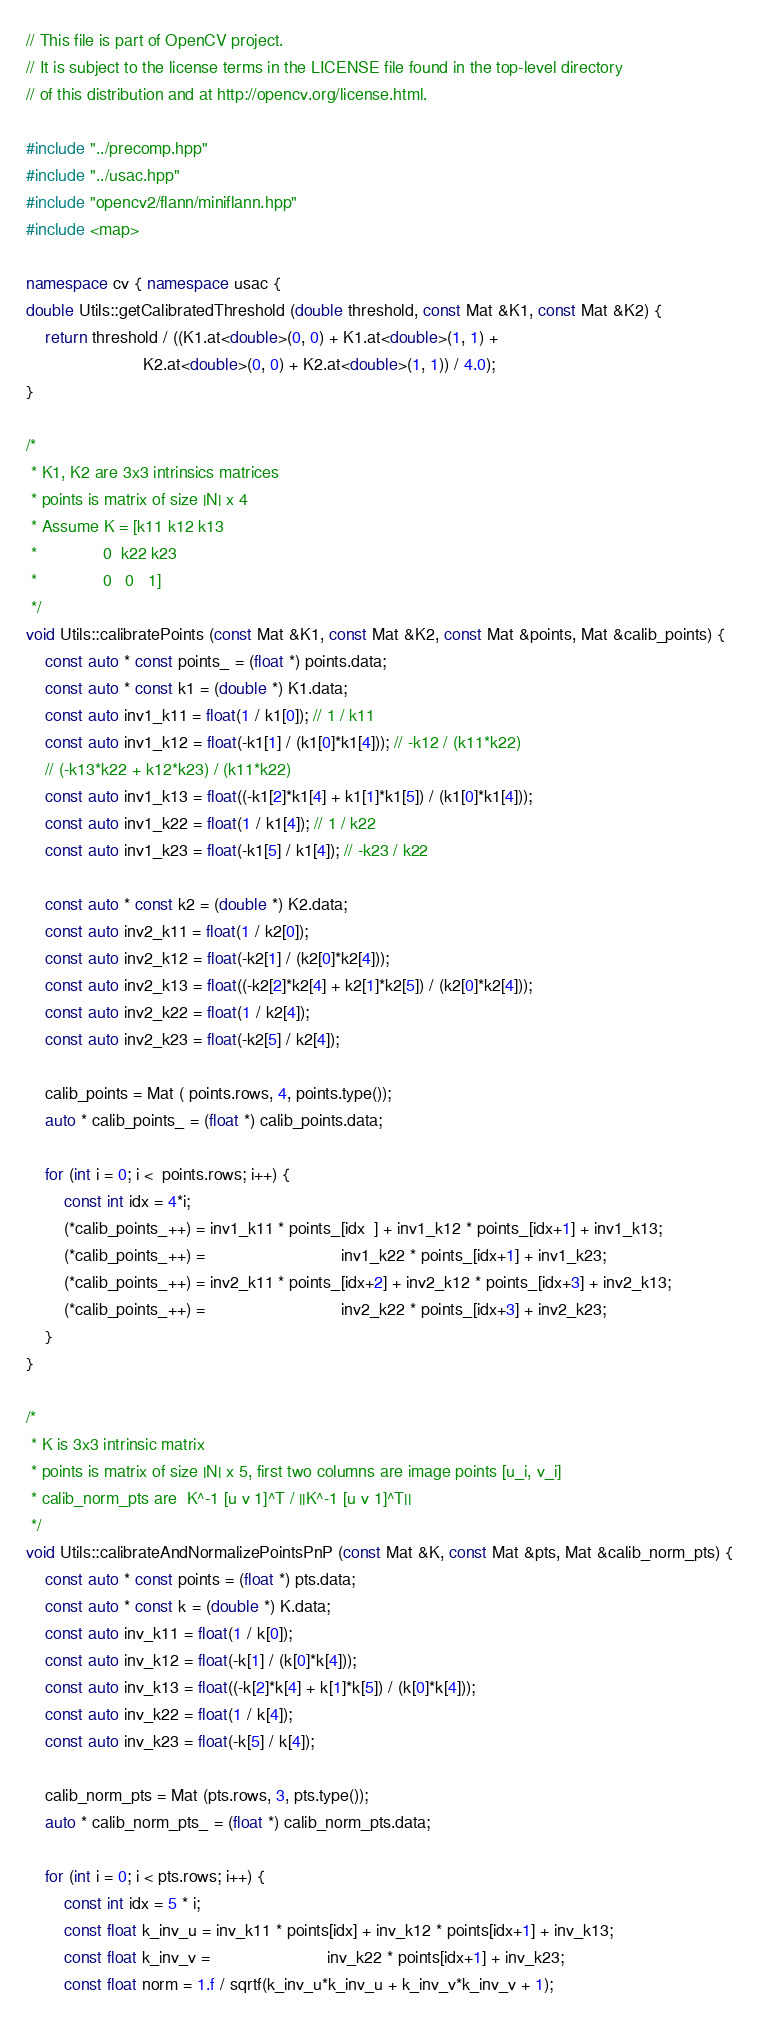<code> <loc_0><loc_0><loc_500><loc_500><_C++_>// This file is part of OpenCV project.
// It is subject to the license terms in the LICENSE file found in the top-level directory
// of this distribution and at http://opencv.org/license.html.

#include "../precomp.hpp"
#include "../usac.hpp"
#include "opencv2/flann/miniflann.hpp"
#include <map>

namespace cv { namespace usac {
double Utils::getCalibratedThreshold (double threshold, const Mat &K1, const Mat &K2) {
    return threshold / ((K1.at<double>(0, 0) + K1.at<double>(1, 1) +
                         K2.at<double>(0, 0) + K2.at<double>(1, 1)) / 4.0);
}

/*
 * K1, K2 are 3x3 intrinsics matrices
 * points is matrix of size |N| x 4
 * Assume K = [k11 k12 k13
 *              0  k22 k23
 *              0   0   1]
 */
void Utils::calibratePoints (const Mat &K1, const Mat &K2, const Mat &points, Mat &calib_points) {
    const auto * const points_ = (float *) points.data;
    const auto * const k1 = (double *) K1.data;
    const auto inv1_k11 = float(1 / k1[0]); // 1 / k11
    const auto inv1_k12 = float(-k1[1] / (k1[0]*k1[4])); // -k12 / (k11*k22)
    // (-k13*k22 + k12*k23) / (k11*k22)
    const auto inv1_k13 = float((-k1[2]*k1[4] + k1[1]*k1[5]) / (k1[0]*k1[4]));
    const auto inv1_k22 = float(1 / k1[4]); // 1 / k22
    const auto inv1_k23 = float(-k1[5] / k1[4]); // -k23 / k22

    const auto * const k2 = (double *) K2.data;
    const auto inv2_k11 = float(1 / k2[0]);
    const auto inv2_k12 = float(-k2[1] / (k2[0]*k2[4]));
    const auto inv2_k13 = float((-k2[2]*k2[4] + k2[1]*k2[5]) / (k2[0]*k2[4]));
    const auto inv2_k22 = float(1 / k2[4]);
    const auto inv2_k23 = float(-k2[5] / k2[4]);

    calib_points = Mat ( points.rows, 4, points.type());
    auto * calib_points_ = (float *) calib_points.data;

    for (int i = 0; i <  points.rows; i++) {
        const int idx = 4*i;
        (*calib_points_++) = inv1_k11 * points_[idx  ] + inv1_k12 * points_[idx+1] + inv1_k13;
        (*calib_points_++) =                             inv1_k22 * points_[idx+1] + inv1_k23;
        (*calib_points_++) = inv2_k11 * points_[idx+2] + inv2_k12 * points_[idx+3] + inv2_k13;
        (*calib_points_++) =                             inv2_k22 * points_[idx+3] + inv2_k23;
    }
}

/*
 * K is 3x3 intrinsic matrix
 * points is matrix of size |N| x 5, first two columns are image points [u_i, v_i]
 * calib_norm_pts are  K^-1 [u v 1]^T / ||K^-1 [u v 1]^T||
 */
void Utils::calibrateAndNormalizePointsPnP (const Mat &K, const Mat &pts, Mat &calib_norm_pts) {
    const auto * const points = (float *) pts.data;
    const auto * const k = (double *) K.data;
    const auto inv_k11 = float(1 / k[0]);
    const auto inv_k12 = float(-k[1] / (k[0]*k[4]));
    const auto inv_k13 = float((-k[2]*k[4] + k[1]*k[5]) / (k[0]*k[4]));
    const auto inv_k22 = float(1 / k[4]);
    const auto inv_k23 = float(-k[5] / k[4]);

    calib_norm_pts = Mat (pts.rows, 3, pts.type());
    auto * calib_norm_pts_ = (float *) calib_norm_pts.data;

    for (int i = 0; i < pts.rows; i++) {
        const int idx = 5 * i;
        const float k_inv_u = inv_k11 * points[idx] + inv_k12 * points[idx+1] + inv_k13;
        const float k_inv_v =                         inv_k22 * points[idx+1] + inv_k23;
        const float norm = 1.f / sqrtf(k_inv_u*k_inv_u + k_inv_v*k_inv_v + 1);</code> 